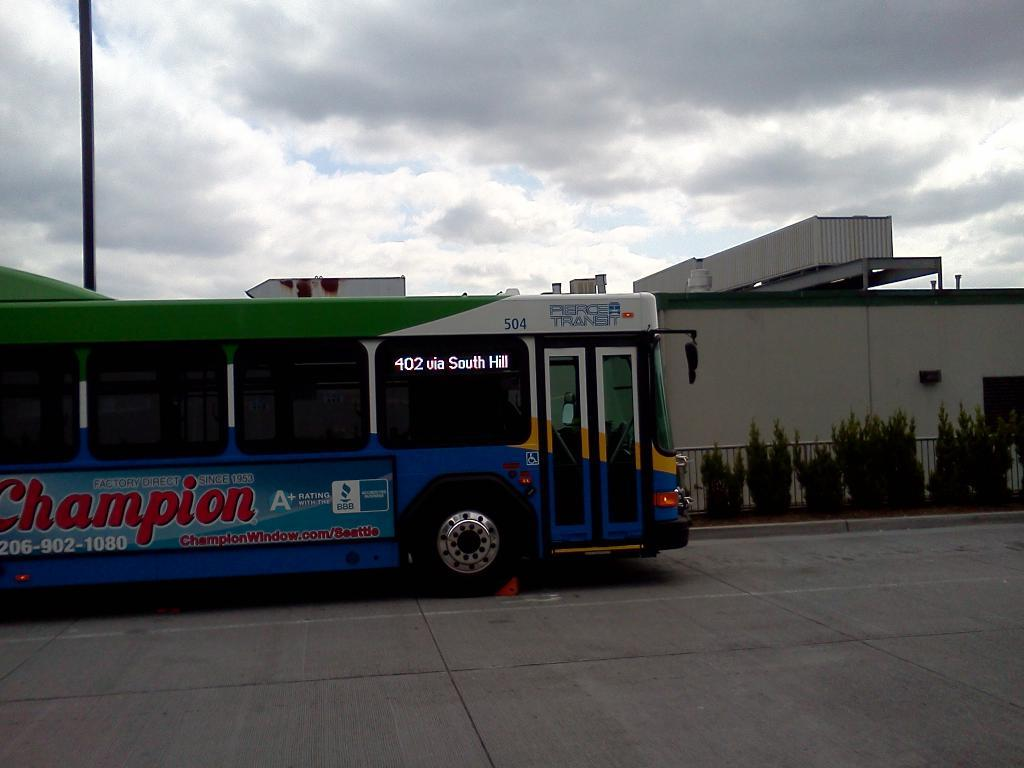What is in the foreground of the image? There is a road in the foreground of the image. What can be seen on the road? There is a vehicle in the image. What type of vegetation is present in the image? There are plants in the image. What separates the different areas in the image? There is a boundary in the image. What type of structure is visible in the image? There is a house structure in the image. What is present near the road in the image? There is a pole in the image. What is visible in the background of the image? The sky is visible in the background of the image. What type of bread can be seen in the image? There is no bread present in the image. What type of eggnog is being served in the image? There is no eggnog present in the image. 